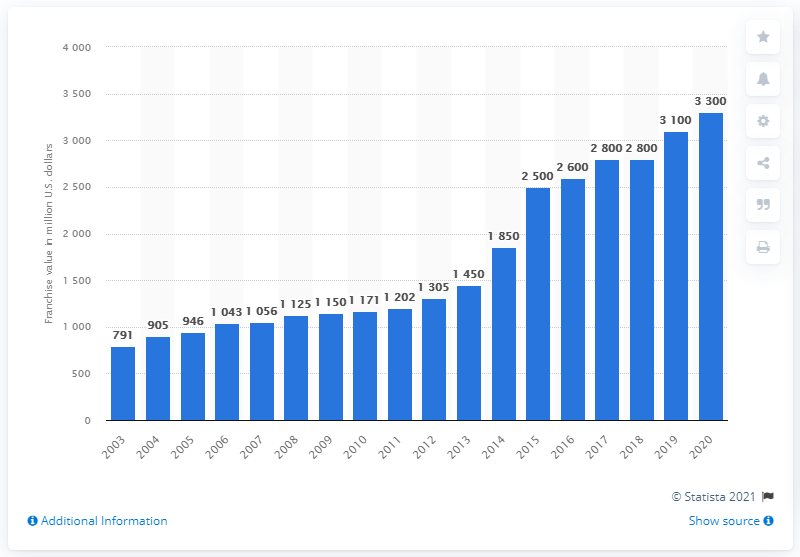Identify some key points in this picture. In 2020, the franchise value of the Houston Texans was approximately $3,300 in U.S. dollars. 